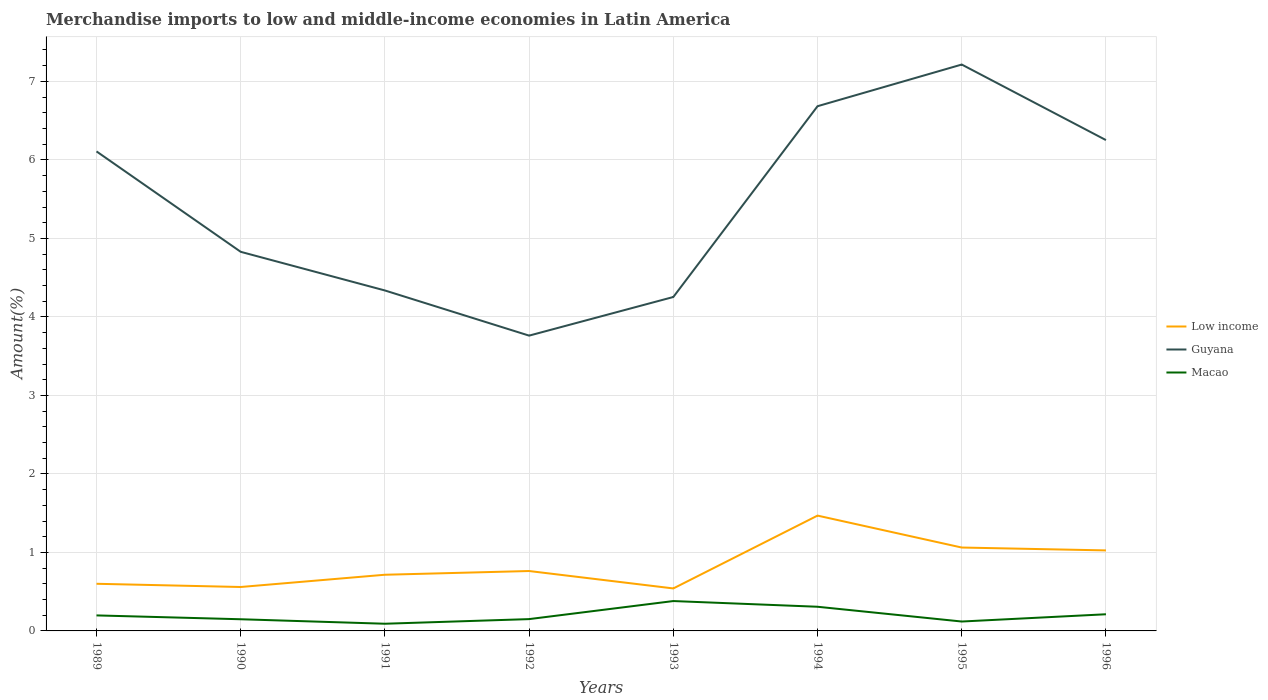Across all years, what is the maximum percentage of amount earned from merchandise imports in Guyana?
Provide a succinct answer. 3.76. In which year was the percentage of amount earned from merchandise imports in Guyana maximum?
Offer a terse response. 1992. What is the total percentage of amount earned from merchandise imports in Macao in the graph?
Your answer should be compact. -0.06. What is the difference between the highest and the second highest percentage of amount earned from merchandise imports in Guyana?
Make the answer very short. 3.45. How many lines are there?
Provide a short and direct response. 3. Does the graph contain grids?
Your response must be concise. Yes. Where does the legend appear in the graph?
Provide a short and direct response. Center right. What is the title of the graph?
Ensure brevity in your answer.  Merchandise imports to low and middle-income economies in Latin America. Does "Afghanistan" appear as one of the legend labels in the graph?
Provide a succinct answer. No. What is the label or title of the X-axis?
Give a very brief answer. Years. What is the label or title of the Y-axis?
Your answer should be compact. Amount(%). What is the Amount(%) of Low income in 1989?
Offer a terse response. 0.6. What is the Amount(%) of Guyana in 1989?
Ensure brevity in your answer.  6.11. What is the Amount(%) of Macao in 1989?
Provide a succinct answer. 0.2. What is the Amount(%) in Low income in 1990?
Offer a terse response. 0.56. What is the Amount(%) of Guyana in 1990?
Give a very brief answer. 4.83. What is the Amount(%) in Macao in 1990?
Your response must be concise. 0.15. What is the Amount(%) of Low income in 1991?
Your response must be concise. 0.72. What is the Amount(%) in Guyana in 1991?
Make the answer very short. 4.34. What is the Amount(%) in Macao in 1991?
Your answer should be very brief. 0.09. What is the Amount(%) in Low income in 1992?
Ensure brevity in your answer.  0.76. What is the Amount(%) in Guyana in 1992?
Offer a terse response. 3.76. What is the Amount(%) in Macao in 1992?
Make the answer very short. 0.15. What is the Amount(%) of Low income in 1993?
Offer a very short reply. 0.54. What is the Amount(%) of Guyana in 1993?
Offer a very short reply. 4.25. What is the Amount(%) in Macao in 1993?
Provide a succinct answer. 0.38. What is the Amount(%) in Low income in 1994?
Offer a terse response. 1.47. What is the Amount(%) of Guyana in 1994?
Your answer should be very brief. 6.68. What is the Amount(%) of Macao in 1994?
Keep it short and to the point. 0.31. What is the Amount(%) of Low income in 1995?
Your response must be concise. 1.06. What is the Amount(%) of Guyana in 1995?
Ensure brevity in your answer.  7.21. What is the Amount(%) of Macao in 1995?
Keep it short and to the point. 0.12. What is the Amount(%) in Low income in 1996?
Provide a short and direct response. 1.03. What is the Amount(%) of Guyana in 1996?
Give a very brief answer. 6.25. What is the Amount(%) in Macao in 1996?
Provide a succinct answer. 0.21. Across all years, what is the maximum Amount(%) of Low income?
Keep it short and to the point. 1.47. Across all years, what is the maximum Amount(%) of Guyana?
Offer a terse response. 7.21. Across all years, what is the maximum Amount(%) in Macao?
Ensure brevity in your answer.  0.38. Across all years, what is the minimum Amount(%) of Low income?
Provide a short and direct response. 0.54. Across all years, what is the minimum Amount(%) in Guyana?
Ensure brevity in your answer.  3.76. Across all years, what is the minimum Amount(%) in Macao?
Provide a succinct answer. 0.09. What is the total Amount(%) of Low income in the graph?
Ensure brevity in your answer.  6.74. What is the total Amount(%) of Guyana in the graph?
Provide a short and direct response. 43.44. What is the total Amount(%) of Macao in the graph?
Offer a terse response. 1.61. What is the difference between the Amount(%) in Low income in 1989 and that in 1990?
Provide a short and direct response. 0.04. What is the difference between the Amount(%) of Guyana in 1989 and that in 1990?
Ensure brevity in your answer.  1.28. What is the difference between the Amount(%) of Macao in 1989 and that in 1990?
Provide a short and direct response. 0.05. What is the difference between the Amount(%) in Low income in 1989 and that in 1991?
Ensure brevity in your answer.  -0.12. What is the difference between the Amount(%) of Guyana in 1989 and that in 1991?
Give a very brief answer. 1.77. What is the difference between the Amount(%) in Macao in 1989 and that in 1991?
Keep it short and to the point. 0.11. What is the difference between the Amount(%) in Low income in 1989 and that in 1992?
Keep it short and to the point. -0.16. What is the difference between the Amount(%) in Guyana in 1989 and that in 1992?
Offer a terse response. 2.35. What is the difference between the Amount(%) in Macao in 1989 and that in 1992?
Make the answer very short. 0.05. What is the difference between the Amount(%) in Low income in 1989 and that in 1993?
Your response must be concise. 0.06. What is the difference between the Amount(%) in Guyana in 1989 and that in 1993?
Provide a short and direct response. 1.85. What is the difference between the Amount(%) of Macao in 1989 and that in 1993?
Ensure brevity in your answer.  -0.18. What is the difference between the Amount(%) in Low income in 1989 and that in 1994?
Provide a short and direct response. -0.87. What is the difference between the Amount(%) in Guyana in 1989 and that in 1994?
Provide a succinct answer. -0.58. What is the difference between the Amount(%) of Macao in 1989 and that in 1994?
Offer a very short reply. -0.11. What is the difference between the Amount(%) in Low income in 1989 and that in 1995?
Provide a short and direct response. -0.46. What is the difference between the Amount(%) in Guyana in 1989 and that in 1995?
Provide a short and direct response. -1.11. What is the difference between the Amount(%) of Macao in 1989 and that in 1995?
Make the answer very short. 0.08. What is the difference between the Amount(%) in Low income in 1989 and that in 1996?
Provide a succinct answer. -0.43. What is the difference between the Amount(%) in Guyana in 1989 and that in 1996?
Your response must be concise. -0.14. What is the difference between the Amount(%) of Macao in 1989 and that in 1996?
Provide a short and direct response. -0.01. What is the difference between the Amount(%) in Low income in 1990 and that in 1991?
Your response must be concise. -0.16. What is the difference between the Amount(%) in Guyana in 1990 and that in 1991?
Make the answer very short. 0.49. What is the difference between the Amount(%) of Macao in 1990 and that in 1991?
Your response must be concise. 0.06. What is the difference between the Amount(%) of Low income in 1990 and that in 1992?
Make the answer very short. -0.2. What is the difference between the Amount(%) of Guyana in 1990 and that in 1992?
Offer a terse response. 1.07. What is the difference between the Amount(%) in Macao in 1990 and that in 1992?
Make the answer very short. -0. What is the difference between the Amount(%) of Low income in 1990 and that in 1993?
Offer a very short reply. 0.02. What is the difference between the Amount(%) in Guyana in 1990 and that in 1993?
Your response must be concise. 0.58. What is the difference between the Amount(%) of Macao in 1990 and that in 1993?
Keep it short and to the point. -0.23. What is the difference between the Amount(%) of Low income in 1990 and that in 1994?
Ensure brevity in your answer.  -0.91. What is the difference between the Amount(%) of Guyana in 1990 and that in 1994?
Ensure brevity in your answer.  -1.85. What is the difference between the Amount(%) in Macao in 1990 and that in 1994?
Your answer should be very brief. -0.16. What is the difference between the Amount(%) in Low income in 1990 and that in 1995?
Offer a terse response. -0.5. What is the difference between the Amount(%) in Guyana in 1990 and that in 1995?
Your answer should be compact. -2.39. What is the difference between the Amount(%) in Macao in 1990 and that in 1995?
Provide a short and direct response. 0.03. What is the difference between the Amount(%) in Low income in 1990 and that in 1996?
Offer a very short reply. -0.47. What is the difference between the Amount(%) of Guyana in 1990 and that in 1996?
Keep it short and to the point. -1.42. What is the difference between the Amount(%) in Macao in 1990 and that in 1996?
Make the answer very short. -0.06. What is the difference between the Amount(%) of Low income in 1991 and that in 1992?
Your answer should be very brief. -0.05. What is the difference between the Amount(%) in Guyana in 1991 and that in 1992?
Make the answer very short. 0.58. What is the difference between the Amount(%) of Macao in 1991 and that in 1992?
Your response must be concise. -0.06. What is the difference between the Amount(%) of Low income in 1991 and that in 1993?
Provide a succinct answer. 0.17. What is the difference between the Amount(%) in Guyana in 1991 and that in 1993?
Offer a very short reply. 0.08. What is the difference between the Amount(%) of Macao in 1991 and that in 1993?
Provide a succinct answer. -0.29. What is the difference between the Amount(%) of Low income in 1991 and that in 1994?
Keep it short and to the point. -0.75. What is the difference between the Amount(%) of Guyana in 1991 and that in 1994?
Ensure brevity in your answer.  -2.35. What is the difference between the Amount(%) of Macao in 1991 and that in 1994?
Your answer should be compact. -0.22. What is the difference between the Amount(%) in Low income in 1991 and that in 1995?
Your answer should be very brief. -0.35. What is the difference between the Amount(%) in Guyana in 1991 and that in 1995?
Make the answer very short. -2.88. What is the difference between the Amount(%) of Macao in 1991 and that in 1995?
Your response must be concise. -0.03. What is the difference between the Amount(%) in Low income in 1991 and that in 1996?
Provide a short and direct response. -0.31. What is the difference between the Amount(%) of Guyana in 1991 and that in 1996?
Give a very brief answer. -1.92. What is the difference between the Amount(%) in Macao in 1991 and that in 1996?
Ensure brevity in your answer.  -0.12. What is the difference between the Amount(%) of Low income in 1992 and that in 1993?
Your response must be concise. 0.22. What is the difference between the Amount(%) of Guyana in 1992 and that in 1993?
Provide a short and direct response. -0.49. What is the difference between the Amount(%) in Macao in 1992 and that in 1993?
Provide a succinct answer. -0.23. What is the difference between the Amount(%) in Low income in 1992 and that in 1994?
Keep it short and to the point. -0.71. What is the difference between the Amount(%) in Guyana in 1992 and that in 1994?
Make the answer very short. -2.92. What is the difference between the Amount(%) of Macao in 1992 and that in 1994?
Give a very brief answer. -0.16. What is the difference between the Amount(%) of Low income in 1992 and that in 1995?
Your answer should be compact. -0.3. What is the difference between the Amount(%) of Guyana in 1992 and that in 1995?
Provide a succinct answer. -3.45. What is the difference between the Amount(%) of Macao in 1992 and that in 1995?
Offer a very short reply. 0.03. What is the difference between the Amount(%) in Low income in 1992 and that in 1996?
Keep it short and to the point. -0.26. What is the difference between the Amount(%) in Guyana in 1992 and that in 1996?
Ensure brevity in your answer.  -2.49. What is the difference between the Amount(%) of Macao in 1992 and that in 1996?
Make the answer very short. -0.06. What is the difference between the Amount(%) of Low income in 1993 and that in 1994?
Give a very brief answer. -0.93. What is the difference between the Amount(%) of Guyana in 1993 and that in 1994?
Give a very brief answer. -2.43. What is the difference between the Amount(%) in Macao in 1993 and that in 1994?
Give a very brief answer. 0.07. What is the difference between the Amount(%) of Low income in 1993 and that in 1995?
Your answer should be very brief. -0.52. What is the difference between the Amount(%) of Guyana in 1993 and that in 1995?
Your answer should be compact. -2.96. What is the difference between the Amount(%) of Macao in 1993 and that in 1995?
Provide a short and direct response. 0.26. What is the difference between the Amount(%) in Low income in 1993 and that in 1996?
Offer a very short reply. -0.48. What is the difference between the Amount(%) in Guyana in 1993 and that in 1996?
Give a very brief answer. -2. What is the difference between the Amount(%) of Macao in 1993 and that in 1996?
Your answer should be compact. 0.17. What is the difference between the Amount(%) of Low income in 1994 and that in 1995?
Your response must be concise. 0.41. What is the difference between the Amount(%) of Guyana in 1994 and that in 1995?
Make the answer very short. -0.53. What is the difference between the Amount(%) in Macao in 1994 and that in 1995?
Ensure brevity in your answer.  0.19. What is the difference between the Amount(%) in Low income in 1994 and that in 1996?
Provide a succinct answer. 0.44. What is the difference between the Amount(%) in Guyana in 1994 and that in 1996?
Your response must be concise. 0.43. What is the difference between the Amount(%) in Macao in 1994 and that in 1996?
Make the answer very short. 0.1. What is the difference between the Amount(%) in Low income in 1995 and that in 1996?
Your answer should be very brief. 0.04. What is the difference between the Amount(%) of Guyana in 1995 and that in 1996?
Your answer should be compact. 0.96. What is the difference between the Amount(%) of Macao in 1995 and that in 1996?
Give a very brief answer. -0.09. What is the difference between the Amount(%) of Low income in 1989 and the Amount(%) of Guyana in 1990?
Make the answer very short. -4.23. What is the difference between the Amount(%) in Low income in 1989 and the Amount(%) in Macao in 1990?
Provide a short and direct response. 0.45. What is the difference between the Amount(%) in Guyana in 1989 and the Amount(%) in Macao in 1990?
Make the answer very short. 5.96. What is the difference between the Amount(%) of Low income in 1989 and the Amount(%) of Guyana in 1991?
Make the answer very short. -3.74. What is the difference between the Amount(%) of Low income in 1989 and the Amount(%) of Macao in 1991?
Offer a terse response. 0.51. What is the difference between the Amount(%) of Guyana in 1989 and the Amount(%) of Macao in 1991?
Make the answer very short. 6.02. What is the difference between the Amount(%) in Low income in 1989 and the Amount(%) in Guyana in 1992?
Give a very brief answer. -3.16. What is the difference between the Amount(%) of Low income in 1989 and the Amount(%) of Macao in 1992?
Make the answer very short. 0.45. What is the difference between the Amount(%) in Guyana in 1989 and the Amount(%) in Macao in 1992?
Ensure brevity in your answer.  5.96. What is the difference between the Amount(%) of Low income in 1989 and the Amount(%) of Guyana in 1993?
Offer a very short reply. -3.65. What is the difference between the Amount(%) in Low income in 1989 and the Amount(%) in Macao in 1993?
Give a very brief answer. 0.22. What is the difference between the Amount(%) of Guyana in 1989 and the Amount(%) of Macao in 1993?
Your answer should be very brief. 5.73. What is the difference between the Amount(%) in Low income in 1989 and the Amount(%) in Guyana in 1994?
Keep it short and to the point. -6.08. What is the difference between the Amount(%) in Low income in 1989 and the Amount(%) in Macao in 1994?
Give a very brief answer. 0.29. What is the difference between the Amount(%) of Guyana in 1989 and the Amount(%) of Macao in 1994?
Offer a terse response. 5.8. What is the difference between the Amount(%) in Low income in 1989 and the Amount(%) in Guyana in 1995?
Provide a short and direct response. -6.61. What is the difference between the Amount(%) of Low income in 1989 and the Amount(%) of Macao in 1995?
Offer a terse response. 0.48. What is the difference between the Amount(%) in Guyana in 1989 and the Amount(%) in Macao in 1995?
Keep it short and to the point. 5.99. What is the difference between the Amount(%) in Low income in 1989 and the Amount(%) in Guyana in 1996?
Ensure brevity in your answer.  -5.65. What is the difference between the Amount(%) in Low income in 1989 and the Amount(%) in Macao in 1996?
Provide a short and direct response. 0.39. What is the difference between the Amount(%) in Guyana in 1989 and the Amount(%) in Macao in 1996?
Offer a very short reply. 5.9. What is the difference between the Amount(%) of Low income in 1990 and the Amount(%) of Guyana in 1991?
Provide a short and direct response. -3.78. What is the difference between the Amount(%) of Low income in 1990 and the Amount(%) of Macao in 1991?
Keep it short and to the point. 0.47. What is the difference between the Amount(%) of Guyana in 1990 and the Amount(%) of Macao in 1991?
Ensure brevity in your answer.  4.74. What is the difference between the Amount(%) of Low income in 1990 and the Amount(%) of Guyana in 1992?
Make the answer very short. -3.2. What is the difference between the Amount(%) of Low income in 1990 and the Amount(%) of Macao in 1992?
Give a very brief answer. 0.41. What is the difference between the Amount(%) of Guyana in 1990 and the Amount(%) of Macao in 1992?
Keep it short and to the point. 4.68. What is the difference between the Amount(%) in Low income in 1990 and the Amount(%) in Guyana in 1993?
Provide a short and direct response. -3.69. What is the difference between the Amount(%) of Low income in 1990 and the Amount(%) of Macao in 1993?
Provide a succinct answer. 0.18. What is the difference between the Amount(%) of Guyana in 1990 and the Amount(%) of Macao in 1993?
Provide a short and direct response. 4.45. What is the difference between the Amount(%) of Low income in 1990 and the Amount(%) of Guyana in 1994?
Your response must be concise. -6.12. What is the difference between the Amount(%) of Low income in 1990 and the Amount(%) of Macao in 1994?
Give a very brief answer. 0.25. What is the difference between the Amount(%) of Guyana in 1990 and the Amount(%) of Macao in 1994?
Ensure brevity in your answer.  4.52. What is the difference between the Amount(%) of Low income in 1990 and the Amount(%) of Guyana in 1995?
Offer a terse response. -6.66. What is the difference between the Amount(%) in Low income in 1990 and the Amount(%) in Macao in 1995?
Keep it short and to the point. 0.44. What is the difference between the Amount(%) in Guyana in 1990 and the Amount(%) in Macao in 1995?
Your response must be concise. 4.71. What is the difference between the Amount(%) in Low income in 1990 and the Amount(%) in Guyana in 1996?
Provide a succinct answer. -5.69. What is the difference between the Amount(%) in Low income in 1990 and the Amount(%) in Macao in 1996?
Keep it short and to the point. 0.35. What is the difference between the Amount(%) in Guyana in 1990 and the Amount(%) in Macao in 1996?
Provide a succinct answer. 4.62. What is the difference between the Amount(%) in Low income in 1991 and the Amount(%) in Guyana in 1992?
Your answer should be compact. -3.05. What is the difference between the Amount(%) in Low income in 1991 and the Amount(%) in Macao in 1992?
Ensure brevity in your answer.  0.57. What is the difference between the Amount(%) of Guyana in 1991 and the Amount(%) of Macao in 1992?
Offer a terse response. 4.19. What is the difference between the Amount(%) of Low income in 1991 and the Amount(%) of Guyana in 1993?
Offer a terse response. -3.54. What is the difference between the Amount(%) of Low income in 1991 and the Amount(%) of Macao in 1993?
Your answer should be very brief. 0.34. What is the difference between the Amount(%) of Guyana in 1991 and the Amount(%) of Macao in 1993?
Ensure brevity in your answer.  3.96. What is the difference between the Amount(%) of Low income in 1991 and the Amount(%) of Guyana in 1994?
Offer a very short reply. -5.97. What is the difference between the Amount(%) in Low income in 1991 and the Amount(%) in Macao in 1994?
Your response must be concise. 0.41. What is the difference between the Amount(%) in Guyana in 1991 and the Amount(%) in Macao in 1994?
Provide a succinct answer. 4.03. What is the difference between the Amount(%) of Low income in 1991 and the Amount(%) of Guyana in 1995?
Provide a succinct answer. -6.5. What is the difference between the Amount(%) of Low income in 1991 and the Amount(%) of Macao in 1995?
Provide a succinct answer. 0.6. What is the difference between the Amount(%) of Guyana in 1991 and the Amount(%) of Macao in 1995?
Your response must be concise. 4.22. What is the difference between the Amount(%) in Low income in 1991 and the Amount(%) in Guyana in 1996?
Offer a very short reply. -5.54. What is the difference between the Amount(%) of Low income in 1991 and the Amount(%) of Macao in 1996?
Provide a short and direct response. 0.5. What is the difference between the Amount(%) of Guyana in 1991 and the Amount(%) of Macao in 1996?
Keep it short and to the point. 4.12. What is the difference between the Amount(%) in Low income in 1992 and the Amount(%) in Guyana in 1993?
Keep it short and to the point. -3.49. What is the difference between the Amount(%) in Low income in 1992 and the Amount(%) in Macao in 1993?
Your answer should be very brief. 0.38. What is the difference between the Amount(%) in Guyana in 1992 and the Amount(%) in Macao in 1993?
Provide a succinct answer. 3.38. What is the difference between the Amount(%) of Low income in 1992 and the Amount(%) of Guyana in 1994?
Offer a very short reply. -5.92. What is the difference between the Amount(%) of Low income in 1992 and the Amount(%) of Macao in 1994?
Keep it short and to the point. 0.46. What is the difference between the Amount(%) of Guyana in 1992 and the Amount(%) of Macao in 1994?
Your response must be concise. 3.45. What is the difference between the Amount(%) of Low income in 1992 and the Amount(%) of Guyana in 1995?
Ensure brevity in your answer.  -6.45. What is the difference between the Amount(%) of Low income in 1992 and the Amount(%) of Macao in 1995?
Offer a terse response. 0.64. What is the difference between the Amount(%) of Guyana in 1992 and the Amount(%) of Macao in 1995?
Make the answer very short. 3.64. What is the difference between the Amount(%) of Low income in 1992 and the Amount(%) of Guyana in 1996?
Offer a terse response. -5.49. What is the difference between the Amount(%) of Low income in 1992 and the Amount(%) of Macao in 1996?
Give a very brief answer. 0.55. What is the difference between the Amount(%) in Guyana in 1992 and the Amount(%) in Macao in 1996?
Your answer should be compact. 3.55. What is the difference between the Amount(%) in Low income in 1993 and the Amount(%) in Guyana in 1994?
Offer a very short reply. -6.14. What is the difference between the Amount(%) in Low income in 1993 and the Amount(%) in Macao in 1994?
Keep it short and to the point. 0.23. What is the difference between the Amount(%) of Guyana in 1993 and the Amount(%) of Macao in 1994?
Provide a succinct answer. 3.95. What is the difference between the Amount(%) of Low income in 1993 and the Amount(%) of Guyana in 1995?
Give a very brief answer. -6.67. What is the difference between the Amount(%) of Low income in 1993 and the Amount(%) of Macao in 1995?
Make the answer very short. 0.42. What is the difference between the Amount(%) of Guyana in 1993 and the Amount(%) of Macao in 1995?
Keep it short and to the point. 4.13. What is the difference between the Amount(%) in Low income in 1993 and the Amount(%) in Guyana in 1996?
Provide a short and direct response. -5.71. What is the difference between the Amount(%) in Low income in 1993 and the Amount(%) in Macao in 1996?
Give a very brief answer. 0.33. What is the difference between the Amount(%) in Guyana in 1993 and the Amount(%) in Macao in 1996?
Your answer should be compact. 4.04. What is the difference between the Amount(%) of Low income in 1994 and the Amount(%) of Guyana in 1995?
Ensure brevity in your answer.  -5.75. What is the difference between the Amount(%) of Low income in 1994 and the Amount(%) of Macao in 1995?
Give a very brief answer. 1.35. What is the difference between the Amount(%) in Guyana in 1994 and the Amount(%) in Macao in 1995?
Keep it short and to the point. 6.56. What is the difference between the Amount(%) of Low income in 1994 and the Amount(%) of Guyana in 1996?
Provide a succinct answer. -4.78. What is the difference between the Amount(%) in Low income in 1994 and the Amount(%) in Macao in 1996?
Your response must be concise. 1.26. What is the difference between the Amount(%) of Guyana in 1994 and the Amount(%) of Macao in 1996?
Keep it short and to the point. 6.47. What is the difference between the Amount(%) in Low income in 1995 and the Amount(%) in Guyana in 1996?
Offer a terse response. -5.19. What is the difference between the Amount(%) in Low income in 1995 and the Amount(%) in Macao in 1996?
Your answer should be compact. 0.85. What is the difference between the Amount(%) of Guyana in 1995 and the Amount(%) of Macao in 1996?
Your answer should be very brief. 7. What is the average Amount(%) in Low income per year?
Make the answer very short. 0.84. What is the average Amount(%) of Guyana per year?
Offer a very short reply. 5.43. What is the average Amount(%) of Macao per year?
Make the answer very short. 0.2. In the year 1989, what is the difference between the Amount(%) of Low income and Amount(%) of Guyana?
Your answer should be very brief. -5.51. In the year 1989, what is the difference between the Amount(%) of Low income and Amount(%) of Macao?
Your response must be concise. 0.4. In the year 1989, what is the difference between the Amount(%) of Guyana and Amount(%) of Macao?
Provide a short and direct response. 5.91. In the year 1990, what is the difference between the Amount(%) of Low income and Amount(%) of Guyana?
Offer a terse response. -4.27. In the year 1990, what is the difference between the Amount(%) in Low income and Amount(%) in Macao?
Keep it short and to the point. 0.41. In the year 1990, what is the difference between the Amount(%) in Guyana and Amount(%) in Macao?
Ensure brevity in your answer.  4.68. In the year 1991, what is the difference between the Amount(%) of Low income and Amount(%) of Guyana?
Give a very brief answer. -3.62. In the year 1991, what is the difference between the Amount(%) in Low income and Amount(%) in Macao?
Your response must be concise. 0.62. In the year 1991, what is the difference between the Amount(%) in Guyana and Amount(%) in Macao?
Give a very brief answer. 4.25. In the year 1992, what is the difference between the Amount(%) in Low income and Amount(%) in Guyana?
Offer a terse response. -3. In the year 1992, what is the difference between the Amount(%) in Low income and Amount(%) in Macao?
Give a very brief answer. 0.61. In the year 1992, what is the difference between the Amount(%) of Guyana and Amount(%) of Macao?
Provide a short and direct response. 3.61. In the year 1993, what is the difference between the Amount(%) of Low income and Amount(%) of Guyana?
Your answer should be compact. -3.71. In the year 1993, what is the difference between the Amount(%) in Low income and Amount(%) in Macao?
Make the answer very short. 0.16. In the year 1993, what is the difference between the Amount(%) of Guyana and Amount(%) of Macao?
Offer a terse response. 3.87. In the year 1994, what is the difference between the Amount(%) of Low income and Amount(%) of Guyana?
Give a very brief answer. -5.21. In the year 1994, what is the difference between the Amount(%) of Low income and Amount(%) of Macao?
Provide a short and direct response. 1.16. In the year 1994, what is the difference between the Amount(%) of Guyana and Amount(%) of Macao?
Your answer should be compact. 6.38. In the year 1995, what is the difference between the Amount(%) of Low income and Amount(%) of Guyana?
Offer a terse response. -6.15. In the year 1995, what is the difference between the Amount(%) in Low income and Amount(%) in Macao?
Your answer should be very brief. 0.94. In the year 1995, what is the difference between the Amount(%) in Guyana and Amount(%) in Macao?
Offer a very short reply. 7.1. In the year 1996, what is the difference between the Amount(%) in Low income and Amount(%) in Guyana?
Your answer should be very brief. -5.23. In the year 1996, what is the difference between the Amount(%) in Low income and Amount(%) in Macao?
Your response must be concise. 0.81. In the year 1996, what is the difference between the Amount(%) of Guyana and Amount(%) of Macao?
Your answer should be compact. 6.04. What is the ratio of the Amount(%) of Low income in 1989 to that in 1990?
Offer a very short reply. 1.07. What is the ratio of the Amount(%) in Guyana in 1989 to that in 1990?
Offer a terse response. 1.26. What is the ratio of the Amount(%) of Macao in 1989 to that in 1990?
Ensure brevity in your answer.  1.33. What is the ratio of the Amount(%) in Low income in 1989 to that in 1991?
Offer a terse response. 0.84. What is the ratio of the Amount(%) of Guyana in 1989 to that in 1991?
Your answer should be very brief. 1.41. What is the ratio of the Amount(%) of Macao in 1989 to that in 1991?
Your response must be concise. 2.16. What is the ratio of the Amount(%) of Low income in 1989 to that in 1992?
Give a very brief answer. 0.79. What is the ratio of the Amount(%) of Guyana in 1989 to that in 1992?
Your answer should be very brief. 1.62. What is the ratio of the Amount(%) of Macao in 1989 to that in 1992?
Ensure brevity in your answer.  1.31. What is the ratio of the Amount(%) in Low income in 1989 to that in 1993?
Your answer should be very brief. 1.11. What is the ratio of the Amount(%) in Guyana in 1989 to that in 1993?
Your answer should be compact. 1.44. What is the ratio of the Amount(%) in Macao in 1989 to that in 1993?
Offer a terse response. 0.52. What is the ratio of the Amount(%) in Low income in 1989 to that in 1994?
Give a very brief answer. 0.41. What is the ratio of the Amount(%) in Guyana in 1989 to that in 1994?
Provide a short and direct response. 0.91. What is the ratio of the Amount(%) of Macao in 1989 to that in 1994?
Provide a succinct answer. 0.64. What is the ratio of the Amount(%) of Low income in 1989 to that in 1995?
Ensure brevity in your answer.  0.57. What is the ratio of the Amount(%) in Guyana in 1989 to that in 1995?
Give a very brief answer. 0.85. What is the ratio of the Amount(%) in Macao in 1989 to that in 1995?
Make the answer very short. 1.65. What is the ratio of the Amount(%) in Low income in 1989 to that in 1996?
Keep it short and to the point. 0.59. What is the ratio of the Amount(%) in Guyana in 1989 to that in 1996?
Your answer should be compact. 0.98. What is the ratio of the Amount(%) in Macao in 1989 to that in 1996?
Offer a terse response. 0.93. What is the ratio of the Amount(%) of Low income in 1990 to that in 1991?
Your response must be concise. 0.78. What is the ratio of the Amount(%) of Guyana in 1990 to that in 1991?
Your answer should be compact. 1.11. What is the ratio of the Amount(%) in Macao in 1990 to that in 1991?
Provide a succinct answer. 1.62. What is the ratio of the Amount(%) in Low income in 1990 to that in 1992?
Your answer should be very brief. 0.73. What is the ratio of the Amount(%) in Guyana in 1990 to that in 1992?
Your response must be concise. 1.28. What is the ratio of the Amount(%) in Macao in 1990 to that in 1992?
Make the answer very short. 0.99. What is the ratio of the Amount(%) of Low income in 1990 to that in 1993?
Ensure brevity in your answer.  1.03. What is the ratio of the Amount(%) in Guyana in 1990 to that in 1993?
Your answer should be very brief. 1.14. What is the ratio of the Amount(%) of Macao in 1990 to that in 1993?
Keep it short and to the point. 0.39. What is the ratio of the Amount(%) of Low income in 1990 to that in 1994?
Offer a terse response. 0.38. What is the ratio of the Amount(%) of Guyana in 1990 to that in 1994?
Keep it short and to the point. 0.72. What is the ratio of the Amount(%) in Macao in 1990 to that in 1994?
Provide a succinct answer. 0.48. What is the ratio of the Amount(%) of Low income in 1990 to that in 1995?
Your response must be concise. 0.53. What is the ratio of the Amount(%) of Guyana in 1990 to that in 1995?
Your answer should be very brief. 0.67. What is the ratio of the Amount(%) in Macao in 1990 to that in 1995?
Offer a very short reply. 1.24. What is the ratio of the Amount(%) in Low income in 1990 to that in 1996?
Keep it short and to the point. 0.55. What is the ratio of the Amount(%) in Guyana in 1990 to that in 1996?
Provide a short and direct response. 0.77. What is the ratio of the Amount(%) of Macao in 1990 to that in 1996?
Offer a terse response. 0.7. What is the ratio of the Amount(%) in Low income in 1991 to that in 1992?
Provide a short and direct response. 0.94. What is the ratio of the Amount(%) in Guyana in 1991 to that in 1992?
Provide a short and direct response. 1.15. What is the ratio of the Amount(%) in Macao in 1991 to that in 1992?
Give a very brief answer. 0.61. What is the ratio of the Amount(%) of Low income in 1991 to that in 1993?
Give a very brief answer. 1.32. What is the ratio of the Amount(%) of Guyana in 1991 to that in 1993?
Your response must be concise. 1.02. What is the ratio of the Amount(%) of Macao in 1991 to that in 1993?
Provide a short and direct response. 0.24. What is the ratio of the Amount(%) in Low income in 1991 to that in 1994?
Provide a succinct answer. 0.49. What is the ratio of the Amount(%) in Guyana in 1991 to that in 1994?
Provide a succinct answer. 0.65. What is the ratio of the Amount(%) of Macao in 1991 to that in 1994?
Provide a succinct answer. 0.3. What is the ratio of the Amount(%) in Low income in 1991 to that in 1995?
Offer a very short reply. 0.67. What is the ratio of the Amount(%) in Guyana in 1991 to that in 1995?
Offer a terse response. 0.6. What is the ratio of the Amount(%) in Macao in 1991 to that in 1995?
Offer a very short reply. 0.76. What is the ratio of the Amount(%) in Low income in 1991 to that in 1996?
Make the answer very short. 0.7. What is the ratio of the Amount(%) in Guyana in 1991 to that in 1996?
Keep it short and to the point. 0.69. What is the ratio of the Amount(%) in Macao in 1991 to that in 1996?
Provide a short and direct response. 0.43. What is the ratio of the Amount(%) of Low income in 1992 to that in 1993?
Ensure brevity in your answer.  1.41. What is the ratio of the Amount(%) of Guyana in 1992 to that in 1993?
Offer a terse response. 0.88. What is the ratio of the Amount(%) in Macao in 1992 to that in 1993?
Your answer should be compact. 0.4. What is the ratio of the Amount(%) of Low income in 1992 to that in 1994?
Provide a short and direct response. 0.52. What is the ratio of the Amount(%) of Guyana in 1992 to that in 1994?
Your answer should be compact. 0.56. What is the ratio of the Amount(%) in Macao in 1992 to that in 1994?
Keep it short and to the point. 0.49. What is the ratio of the Amount(%) in Low income in 1992 to that in 1995?
Provide a succinct answer. 0.72. What is the ratio of the Amount(%) in Guyana in 1992 to that in 1995?
Make the answer very short. 0.52. What is the ratio of the Amount(%) in Macao in 1992 to that in 1995?
Ensure brevity in your answer.  1.26. What is the ratio of the Amount(%) of Low income in 1992 to that in 1996?
Provide a succinct answer. 0.74. What is the ratio of the Amount(%) of Guyana in 1992 to that in 1996?
Keep it short and to the point. 0.6. What is the ratio of the Amount(%) of Macao in 1992 to that in 1996?
Make the answer very short. 0.71. What is the ratio of the Amount(%) of Low income in 1993 to that in 1994?
Offer a terse response. 0.37. What is the ratio of the Amount(%) in Guyana in 1993 to that in 1994?
Your response must be concise. 0.64. What is the ratio of the Amount(%) of Macao in 1993 to that in 1994?
Provide a succinct answer. 1.24. What is the ratio of the Amount(%) in Low income in 1993 to that in 1995?
Offer a very short reply. 0.51. What is the ratio of the Amount(%) in Guyana in 1993 to that in 1995?
Make the answer very short. 0.59. What is the ratio of the Amount(%) in Macao in 1993 to that in 1995?
Make the answer very short. 3.18. What is the ratio of the Amount(%) of Low income in 1993 to that in 1996?
Your answer should be very brief. 0.53. What is the ratio of the Amount(%) of Guyana in 1993 to that in 1996?
Keep it short and to the point. 0.68. What is the ratio of the Amount(%) in Macao in 1993 to that in 1996?
Your answer should be very brief. 1.79. What is the ratio of the Amount(%) of Low income in 1994 to that in 1995?
Provide a short and direct response. 1.38. What is the ratio of the Amount(%) in Guyana in 1994 to that in 1995?
Your answer should be very brief. 0.93. What is the ratio of the Amount(%) of Macao in 1994 to that in 1995?
Your response must be concise. 2.57. What is the ratio of the Amount(%) of Low income in 1994 to that in 1996?
Offer a very short reply. 1.43. What is the ratio of the Amount(%) in Guyana in 1994 to that in 1996?
Offer a terse response. 1.07. What is the ratio of the Amount(%) of Macao in 1994 to that in 1996?
Keep it short and to the point. 1.45. What is the ratio of the Amount(%) of Low income in 1995 to that in 1996?
Your answer should be compact. 1.04. What is the ratio of the Amount(%) in Guyana in 1995 to that in 1996?
Ensure brevity in your answer.  1.15. What is the ratio of the Amount(%) in Macao in 1995 to that in 1996?
Give a very brief answer. 0.56. What is the difference between the highest and the second highest Amount(%) in Low income?
Provide a succinct answer. 0.41. What is the difference between the highest and the second highest Amount(%) of Guyana?
Offer a very short reply. 0.53. What is the difference between the highest and the second highest Amount(%) of Macao?
Your answer should be compact. 0.07. What is the difference between the highest and the lowest Amount(%) of Low income?
Your answer should be compact. 0.93. What is the difference between the highest and the lowest Amount(%) of Guyana?
Offer a terse response. 3.45. What is the difference between the highest and the lowest Amount(%) of Macao?
Keep it short and to the point. 0.29. 